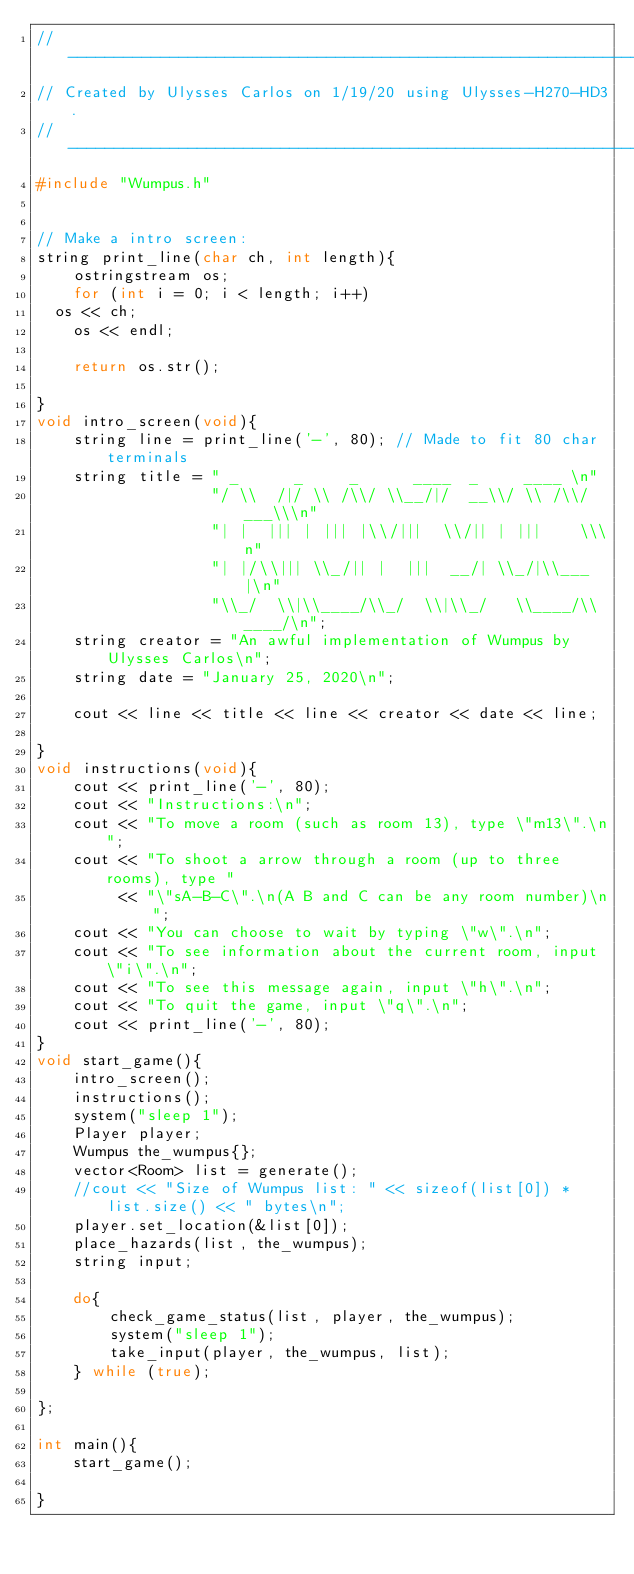Convert code to text. <code><loc_0><loc_0><loc_500><loc_500><_C++_>//--------------------------------------------------------------------------------------------------
// Created by Ulysses Carlos on 1/19/20 using Ulysses-H270-HD3.
//--------------------------------------------------------------------------------------------------
#include "Wumpus.h"


// Make a intro screen:
string print_line(char ch, int length){
    ostringstream os;
    for (int i = 0; i < length; i++)
	os << ch;
    os << endl;

    return os.str();

}
void intro_screen(void){
    string line = print_line('-', 80); // Made to fit 80 char terminals
    string title = " _      _     _      ____  _     ____ \n"
                   "/ \\  /|/ \\ /\\/ \\__/|/  __\\/ \\ /\\/ ___\\\n"
                   "| |  ||| | ||| |\\/|||  \\/|| | |||    \\\n"
                   "| |/\\||| \\_/|| |  |||  __/| \\_/|\\___ |\n"
                   "\\_/  \\|\\____/\\_/  \\|\\_/   \\____/\\____/\n";
    string creator = "An awful implementation of Wumpus by Ulysses Carlos\n";
    string date = "January 25, 2020\n";

    cout << line << title << line << creator << date << line;
    
}
void instructions(void){
    cout << print_line('-', 80);
    cout << "Instructions:\n";
    cout << "To move a room (such as room 13), type \"m13\".\n";
    cout << "To shoot a arrow through a room (up to three rooms), type "
         << "\"sA-B-C\".\n(A B and C can be any room number)\n";
    cout << "You can choose to wait by typing \"w\".\n";
    cout << "To see information about the current room, input \"i\".\n";
    cout << "To see this message again, input \"h\".\n";
    cout << "To quit the game, input \"q\".\n";
    cout << print_line('-', 80);
}
void start_game(){
    intro_screen();
    instructions();
    system("sleep 1");
    Player player;
    Wumpus the_wumpus{};
    vector<Room> list = generate();
    //cout << "Size of Wumpus list: " << sizeof(list[0]) * list.size() << " bytes\n";
    player.set_location(&list[0]);
    place_hazards(list, the_wumpus);
    string input;

    do{
        check_game_status(list, player, the_wumpus);
        system("sleep 1");
        take_input(player, the_wumpus, list);
    } while (true);

};

int main(){
    start_game();

}


</code> 